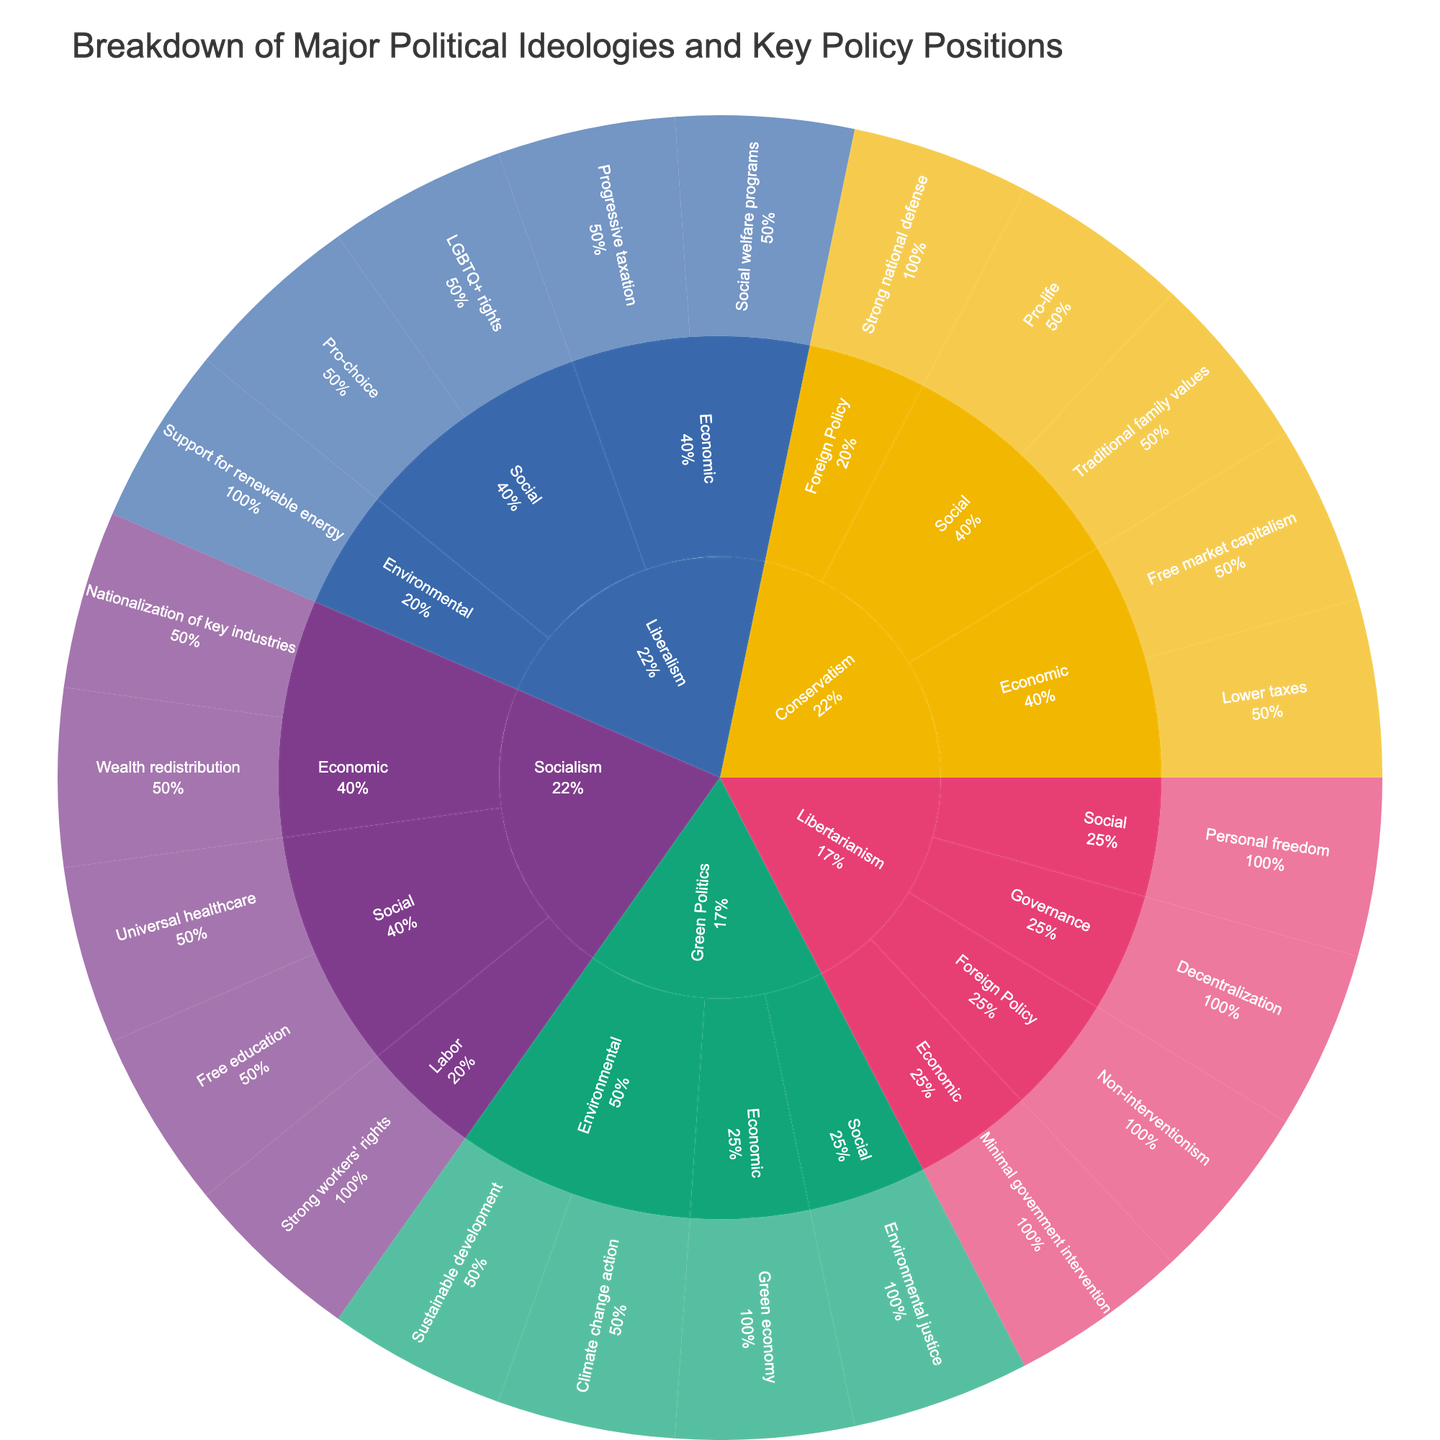What is the main ideology associated with the policy position "Universal healthcare"? To find the main ideology associated with the policy position "Universal healthcare", locate the position in the innermost ring and trace it back through its parent categories. "Universal healthcare" falls under the ideology "Socialism".
Answer: Socialism Which ideology supports "Support for renewable energy"? Identify the "Support for renewable energy" policy position on the plot, then trace back to find its main ideology. The support for renewable energy is under "Liberalism".
Answer: Liberalism How many distinct policy positions are listed under "Conservatism"? Look at the section for Conservatism and count the number of unique policy positions within its branches. There are five policy positions: "Lower taxes", "Free market capitalism", "Traditional family values", "Pro-life", and "Strong national defense".
Answer: 5 Which category has the highest number of policy positions for "Green Politics"? Navigate through the branches under "Green Politics" and count the policy positions in each category. The "Environmental" category has the most with four policy positions.
Answer: Environmental Compare the number of economic policy positions between "Liberalism" and "Socialism". Which has more? Count the economic policy positions under each ideology. "Liberalism" has two: "Progressive taxation" and "Social welfare programs". "Socialism" has two: "Wealth redistribution" and "Nationalization of key industries". Both ideologies have the same number of economic policy positions.
Answer: Equal Which ideology focuses on "Non-interventionism" in foreign policy? Locate the "Non-interventionism" policy position and trace it back through its parent categories. It is under "Libertarianism".
Answer: Libertarianism How many categories of policy positions are listed under "Libertarianism"? Navigate through the branches under "Libertarianism" and count the number of different categories. There are four categories: "Economic", "Social", "Foreign Policy", and "Governance".
Answer: 4 What is the unique policy position in the "Governance" category? Locate the "Governance" category and see which policy position is listed. It is "Decentralization".
Answer: Decentralization Which ideology has a policy position related to "Climate change action"? Find the "Climate change action" policy position and trace it back through its parent categories. It belongs to "Green Politics".
Answer: Green Politics Among all ideologies, which has the most diverse categorization of policy positions? Evaluate the number of distinct categories under each ideology. "Liberalism", "Socialism", "Libertarianism", and "Green Politics" have multiple categories, but "Libertarianism" stands out with four distinct categories.
Answer: Libertarianism 